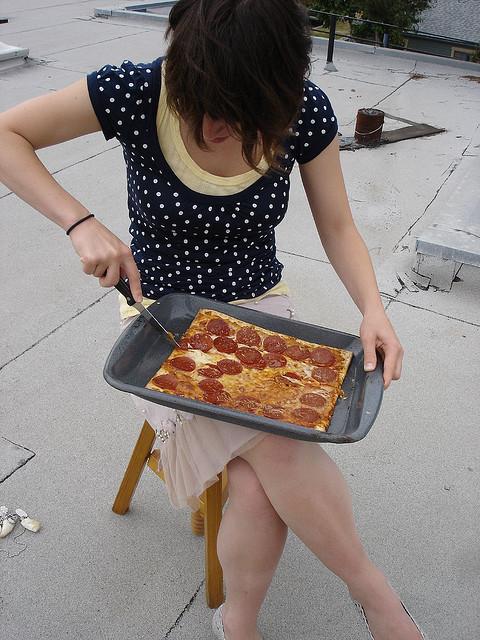What color are the polka dots?
Concise answer only. White. What is she doing to the pizza?
Concise answer only. Cutting it. What food is on the tray?
Answer briefly. Pizza. 